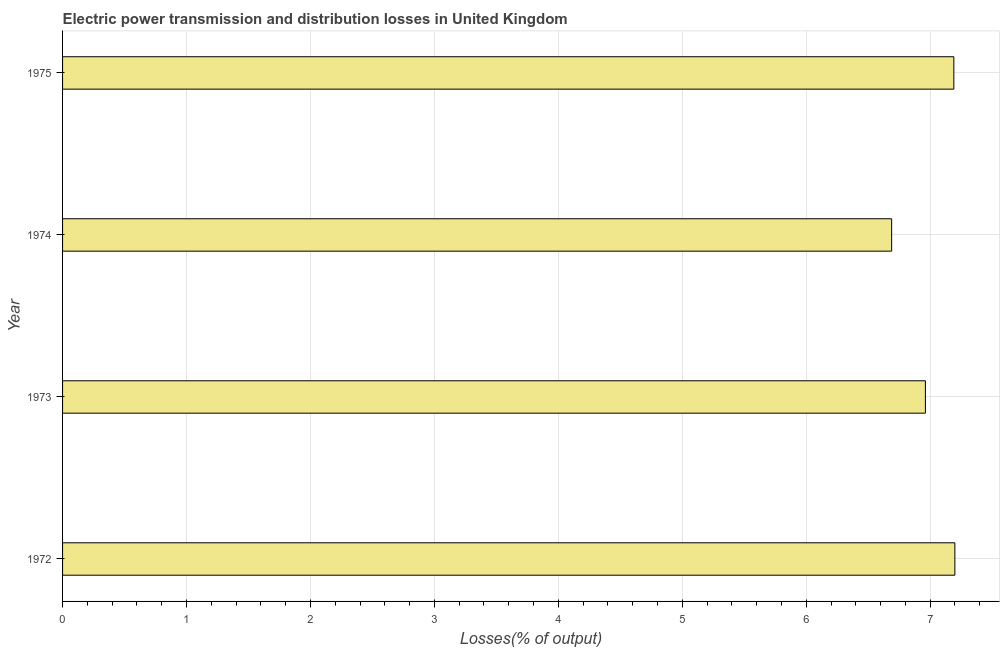Does the graph contain any zero values?
Your answer should be compact. No. What is the title of the graph?
Offer a very short reply. Electric power transmission and distribution losses in United Kingdom. What is the label or title of the X-axis?
Your response must be concise. Losses(% of output). What is the label or title of the Y-axis?
Your answer should be very brief. Year. What is the electric power transmission and distribution losses in 1972?
Your answer should be very brief. 7.2. Across all years, what is the maximum electric power transmission and distribution losses?
Offer a terse response. 7.2. Across all years, what is the minimum electric power transmission and distribution losses?
Your answer should be compact. 6.69. In which year was the electric power transmission and distribution losses maximum?
Keep it short and to the point. 1972. In which year was the electric power transmission and distribution losses minimum?
Your response must be concise. 1974. What is the sum of the electric power transmission and distribution losses?
Provide a short and direct response. 28.04. What is the difference between the electric power transmission and distribution losses in 1974 and 1975?
Your answer should be very brief. -0.5. What is the average electric power transmission and distribution losses per year?
Your answer should be compact. 7.01. What is the median electric power transmission and distribution losses?
Make the answer very short. 7.08. Do a majority of the years between 1974 and 1972 (inclusive) have electric power transmission and distribution losses greater than 2.6 %?
Offer a very short reply. Yes. What is the difference between the highest and the second highest electric power transmission and distribution losses?
Offer a terse response. 0.01. What is the difference between the highest and the lowest electric power transmission and distribution losses?
Your answer should be very brief. 0.51. How many bars are there?
Offer a very short reply. 4. How many years are there in the graph?
Offer a terse response. 4. What is the Losses(% of output) in 1972?
Offer a very short reply. 7.2. What is the Losses(% of output) of 1973?
Offer a terse response. 6.96. What is the Losses(% of output) in 1974?
Your answer should be very brief. 6.69. What is the Losses(% of output) in 1975?
Offer a terse response. 7.19. What is the difference between the Losses(% of output) in 1972 and 1973?
Your answer should be very brief. 0.24. What is the difference between the Losses(% of output) in 1972 and 1974?
Provide a short and direct response. 0.51. What is the difference between the Losses(% of output) in 1972 and 1975?
Provide a short and direct response. 0.01. What is the difference between the Losses(% of output) in 1973 and 1974?
Keep it short and to the point. 0.27. What is the difference between the Losses(% of output) in 1973 and 1975?
Offer a very short reply. -0.23. What is the difference between the Losses(% of output) in 1974 and 1975?
Make the answer very short. -0.5. What is the ratio of the Losses(% of output) in 1972 to that in 1973?
Your response must be concise. 1.03. What is the ratio of the Losses(% of output) in 1972 to that in 1974?
Your response must be concise. 1.08. What is the ratio of the Losses(% of output) in 1972 to that in 1975?
Make the answer very short. 1. What is the ratio of the Losses(% of output) in 1973 to that in 1974?
Provide a succinct answer. 1.04. What is the ratio of the Losses(% of output) in 1973 to that in 1975?
Offer a terse response. 0.97. What is the ratio of the Losses(% of output) in 1974 to that in 1975?
Offer a very short reply. 0.93. 